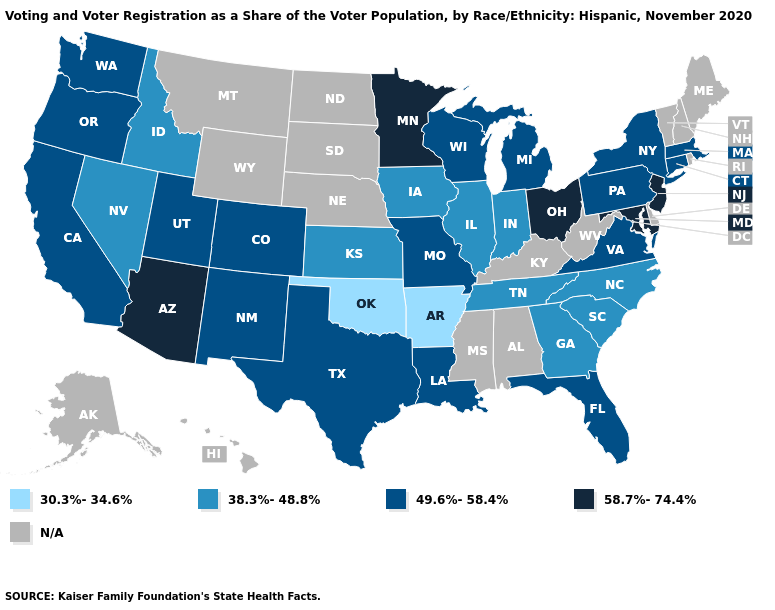Does Florida have the lowest value in the South?
Give a very brief answer. No. Name the states that have a value in the range 49.6%-58.4%?
Short answer required. California, Colorado, Connecticut, Florida, Louisiana, Massachusetts, Michigan, Missouri, New Mexico, New York, Oregon, Pennsylvania, Texas, Utah, Virginia, Washington, Wisconsin. Name the states that have a value in the range 49.6%-58.4%?
Short answer required. California, Colorado, Connecticut, Florida, Louisiana, Massachusetts, Michigan, Missouri, New Mexico, New York, Oregon, Pennsylvania, Texas, Utah, Virginia, Washington, Wisconsin. What is the value of North Dakota?
Quick response, please. N/A. Which states have the highest value in the USA?
Short answer required. Arizona, Maryland, Minnesota, New Jersey, Ohio. Does the map have missing data?
Write a very short answer. Yes. What is the lowest value in states that border Florida?
Be succinct. 38.3%-48.8%. What is the value of New York?
Answer briefly. 49.6%-58.4%. Name the states that have a value in the range 30.3%-34.6%?
Write a very short answer. Arkansas, Oklahoma. What is the highest value in states that border Arizona?
Answer briefly. 49.6%-58.4%. Does Wisconsin have the lowest value in the USA?
Be succinct. No. Which states have the highest value in the USA?
Give a very brief answer. Arizona, Maryland, Minnesota, New Jersey, Ohio. What is the value of Hawaii?
Keep it brief. N/A. 